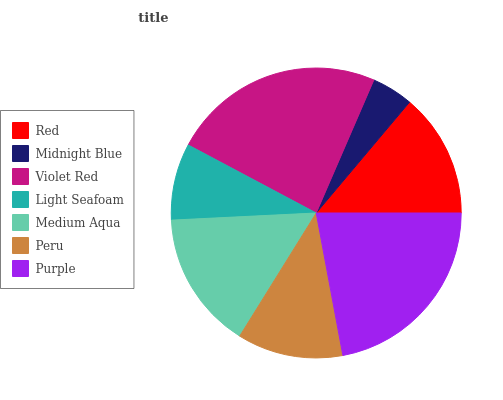Is Midnight Blue the minimum?
Answer yes or no. Yes. Is Violet Red the maximum?
Answer yes or no. Yes. Is Violet Red the minimum?
Answer yes or no. No. Is Midnight Blue the maximum?
Answer yes or no. No. Is Violet Red greater than Midnight Blue?
Answer yes or no. Yes. Is Midnight Blue less than Violet Red?
Answer yes or no. Yes. Is Midnight Blue greater than Violet Red?
Answer yes or no. No. Is Violet Red less than Midnight Blue?
Answer yes or no. No. Is Red the high median?
Answer yes or no. Yes. Is Red the low median?
Answer yes or no. Yes. Is Purple the high median?
Answer yes or no. No. Is Violet Red the low median?
Answer yes or no. No. 